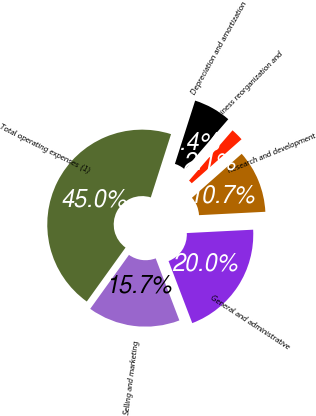Convert chart to OTSL. <chart><loc_0><loc_0><loc_500><loc_500><pie_chart><fcel>Selling and marketing<fcel>General and administrative<fcel>Research and development<fcel>Business reorganization and<fcel>Depreciation and amortization<fcel>Total operating expenses (1)<nl><fcel>15.72%<fcel>20.01%<fcel>10.71%<fcel>2.13%<fcel>6.42%<fcel>45.02%<nl></chart> 